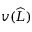Convert formula to latex. <formula><loc_0><loc_0><loc_500><loc_500>v ( \widehat { L } )</formula> 